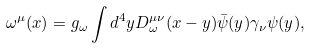<formula> <loc_0><loc_0><loc_500><loc_500>\omega ^ { \mu } ( x ) = g _ { \omega } \int d ^ { 4 } y D _ { \omega } ^ { \mu \nu } ( x - y ) \bar { \psi } ( y ) \gamma _ { \nu } \psi ( y ) ,</formula> 